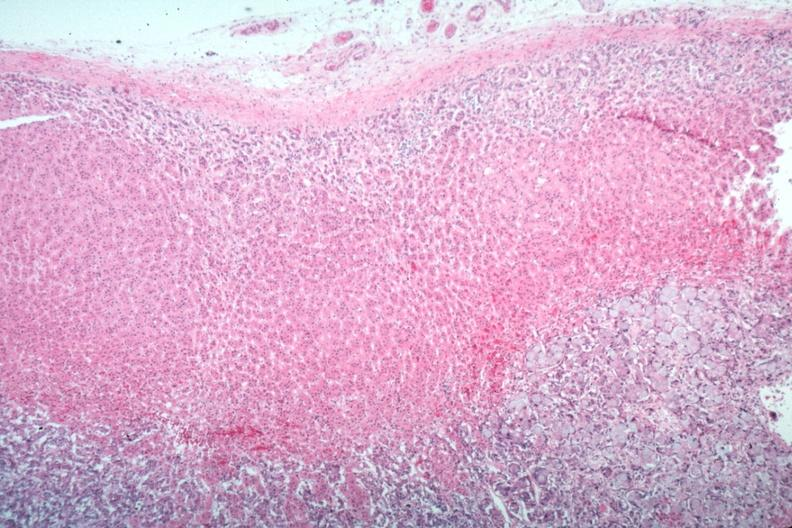what is present?
Answer the question using a single word or phrase. Endocrine 